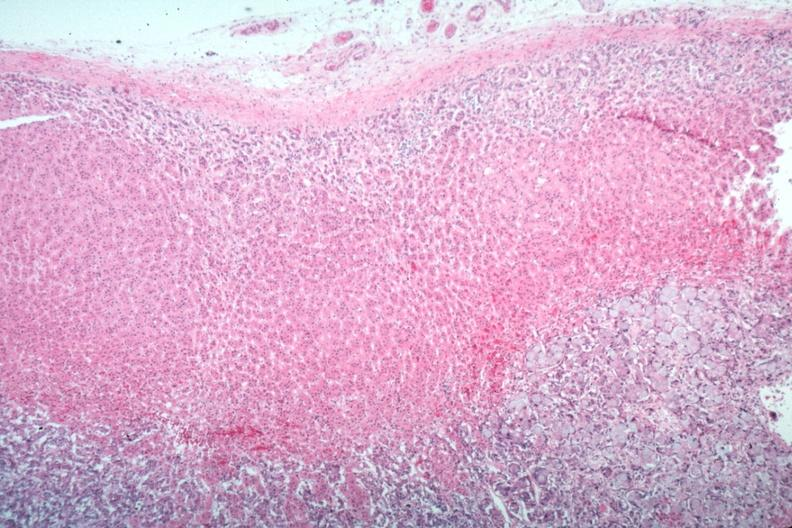what is present?
Answer the question using a single word or phrase. Endocrine 